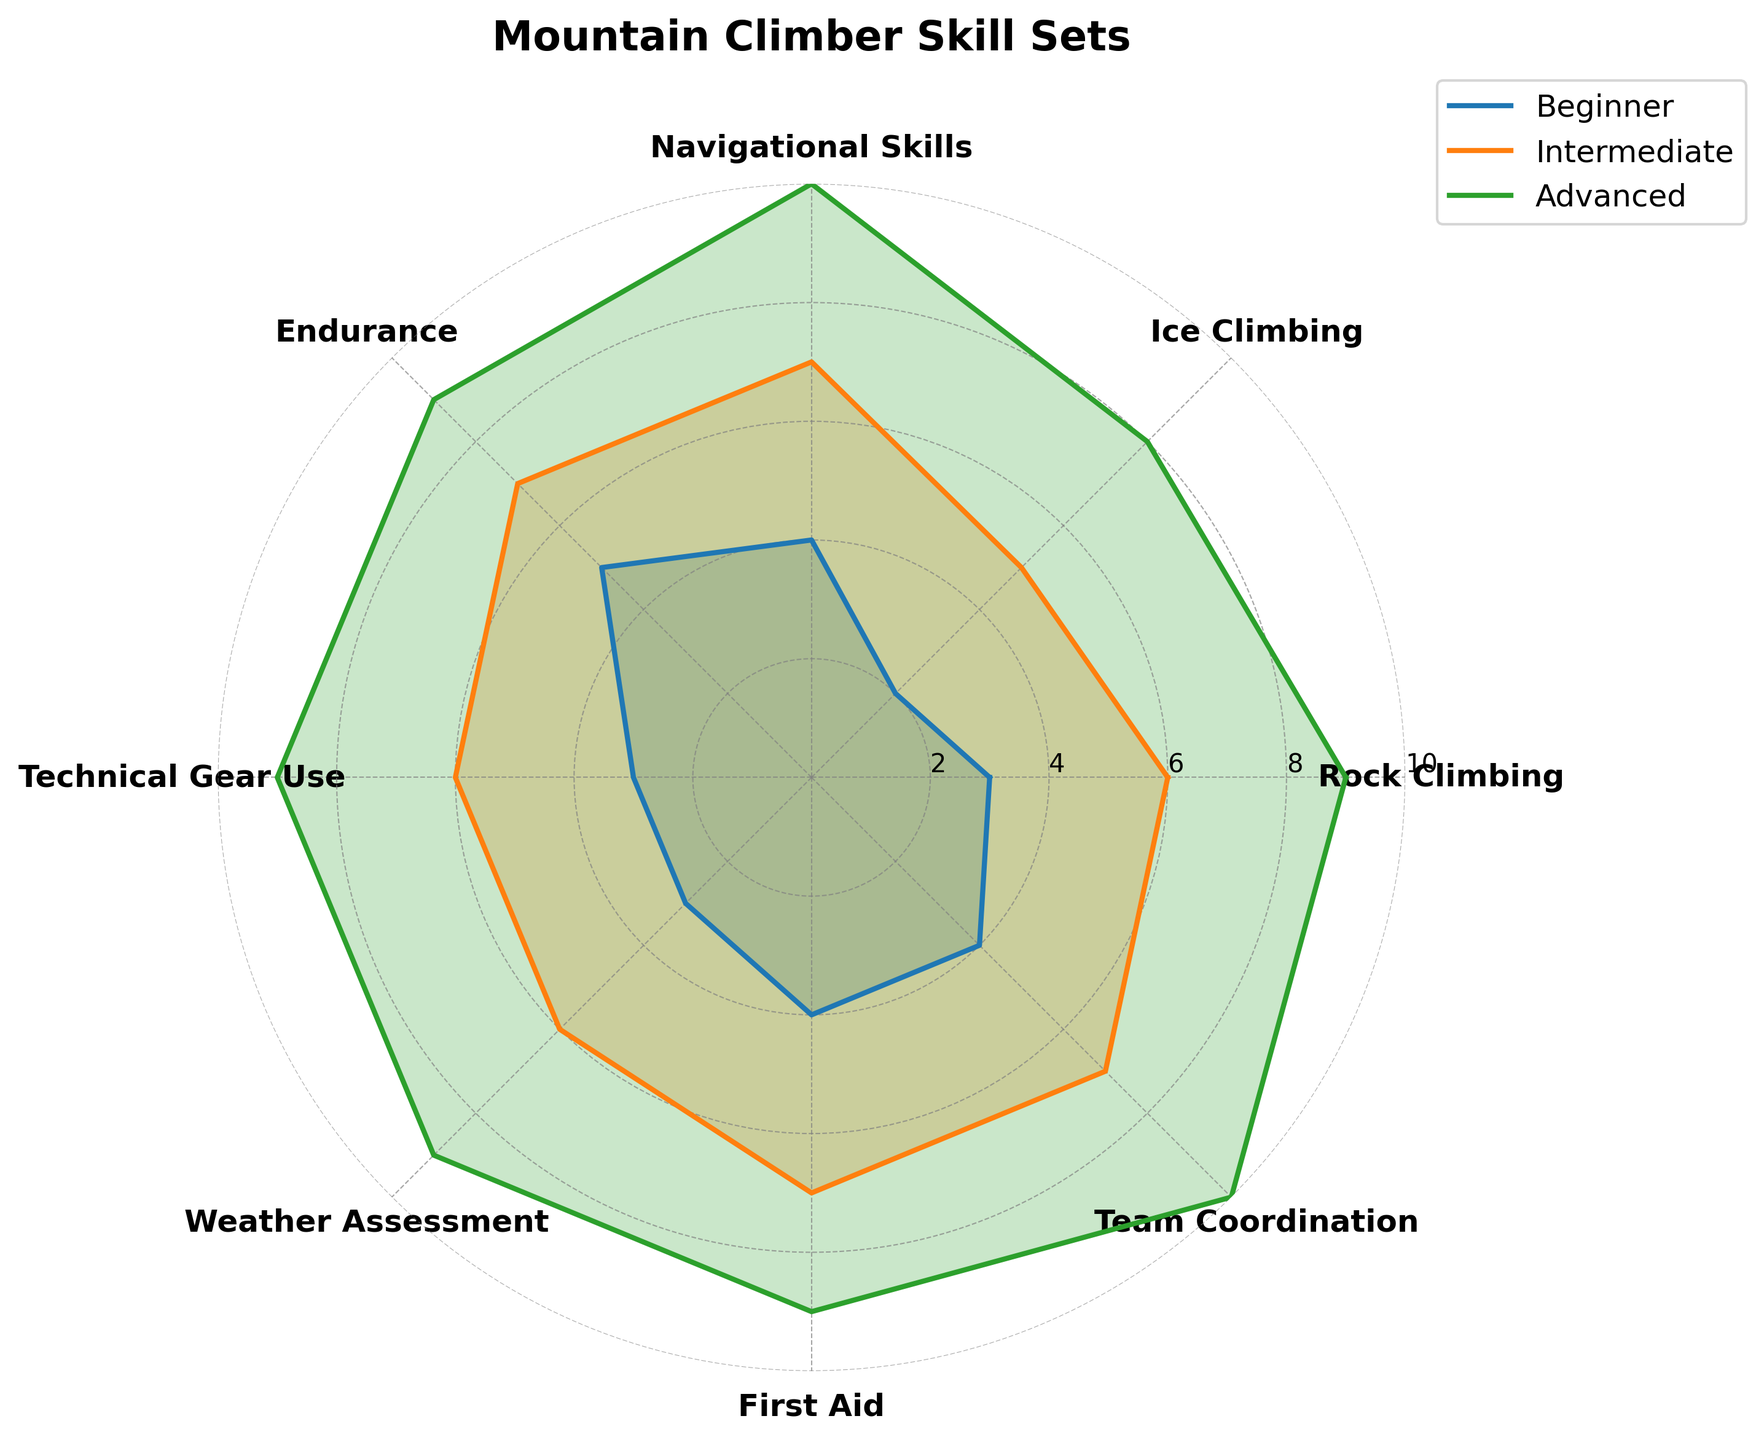What is the highest skill rating for beginners? By looking at the beginner data points on the plot, find the maximum value among all skill categories. The highest value for beginners is in 'Endurance' with a rating of 5.
Answer: 5 Which skill has the same rating across all experience levels? Compare each skill category's ratings across all three experience levels. 'Technical Gear Use' has the same rating of 3, 6, and 9 across Beginner, Intermediate, and Advanced levels.
Answer: Technical Gear Use How does the rating of 'Navigational Skills' for beginners compare to 'Ice Climbing' for intermediates? Identify the values of 'Navigational Skills' for beginners (4) and 'Ice Climbing' for intermediates (5) on the radar chart and compare them numerically.
Answer: 4 is less than 5 What is the average rating for 'Team Coordination' across all experience levels? Add the ratings for 'Team Coordination' from Beginner (4), Intermediate (7), and Advanced (10) and divide by the number of levels (3). (4 + 7 + 10) / 3 = 21 / 3
Answer: 7 Which skill shows the largest improvement from Beginner to Advanced level? Calculate the difference between the Advanced and Beginner ratings for each skill. The largest improvement is 'Navigational Skills,' which improved by 6 points from 4 to 10.
Answer: Navigational Skills Which experience level has the highest average skill rating overall? Sum the ratings for each experience level and divide by the number of skills (8). Calculate the average for Beginner, Intermediate, and Advanced, and compare them.
Beginner: (3+2+4+5+3+3+4+4) / 8 = 28 / 8 = 3.5
Intermediate: (6+5+7+7+6+6+7+7) / 8 = 51 / 8 = 6.375
Advanced: (9+8+10+9+9+9+9+10) / 8 = 73 / 8 = 9.125
Answer: Advanced Which experience level has the most balanced skill ratings (smallest standard deviation)? Calculate the standard deviation for each experience level’s ratings. A lower value indicates more balanced ratings.
Answer: Beginner 